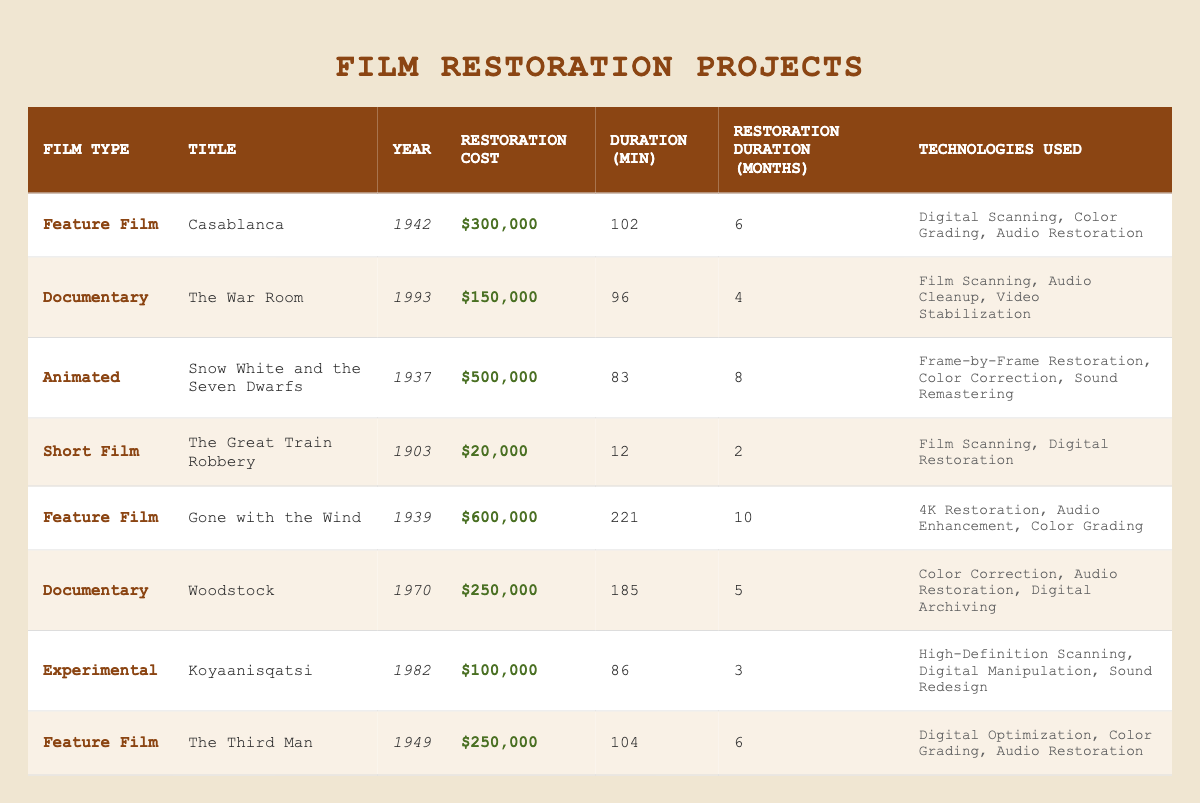What is the restoration cost of "Gone with the Wind"? The restoration cost for "Gone with the Wind," is listed in the table under the "Restoration Cost" column. It shows $600,000.
Answer: $600,000 Which film has the longest restoration duration? To find the longest restoration duration, we examine the "Restoration Duration" column and see that "Gone with the Wind" has the highest value at 10 months.
Answer: 10 months How many feature films are listed in the table? The table shows a total of 4 feature films by counting the "Film Type" column entries labeled as "Feature Film." These films are "Casablanca," "Gone with the Wind," "The Third Man," and "The Third Man."
Answer: 4 What is the average restoration cost for documentaries? The restoration costs for documentaries are $150,000 for "The War Room" and $250,000 for "Woodstock." Adding these amounts gives $400,000, and dividing by the number of documentary films (2) results in an average of $200,000.
Answer: $200,000 Is "Koyaanisqatsi" a feature film? In the table, the "Film Type" for "Koyaanisqatsi" is listed as "Experimental," which means it is not a feature film.
Answer: No Which film restoration project used "Digital Archiving"? Looking at the "Technologies Used" column, "Woodstock" is the only film that lists "Digital Archiving" among its technologies.
Answer: Woodstock Does "Snow White and the Seven Dwarfs" have a higher restoration cost than "The War Room"? Comparing the restoration costs, "Snow White and the Seven Dwarfs" has a cost of $500,000, and "The War Room" has a cost of $150,000. Since $500,000 is greater than $150,000, the answer is yes.
Answer: Yes What is the total duration of all animated films listed? There is only one animated film, "Snow White and the Seven Dwarfs," with a duration of 83 minutes. Therefore, the total duration for animated films is simply 83 minutes.
Answer: 83 minutes How many technologies were used for the restoration of "Casablanca"? The "Technologies Used" column for "Casablanca" lists three technologies: Digital Scanning, Color Grading, and Audio Restoration. Thus, the number of technologies used is three.
Answer: 3 Which film has both color grading and audio restoration as technologies used in its restoration? By examining the "Technologies Used" column, both "Casablanca" and "The Third Man" include "Color Grading" and "Audio Restoration." Thus, both films meet this criterion.
Answer: Casablanca and The Third Man 